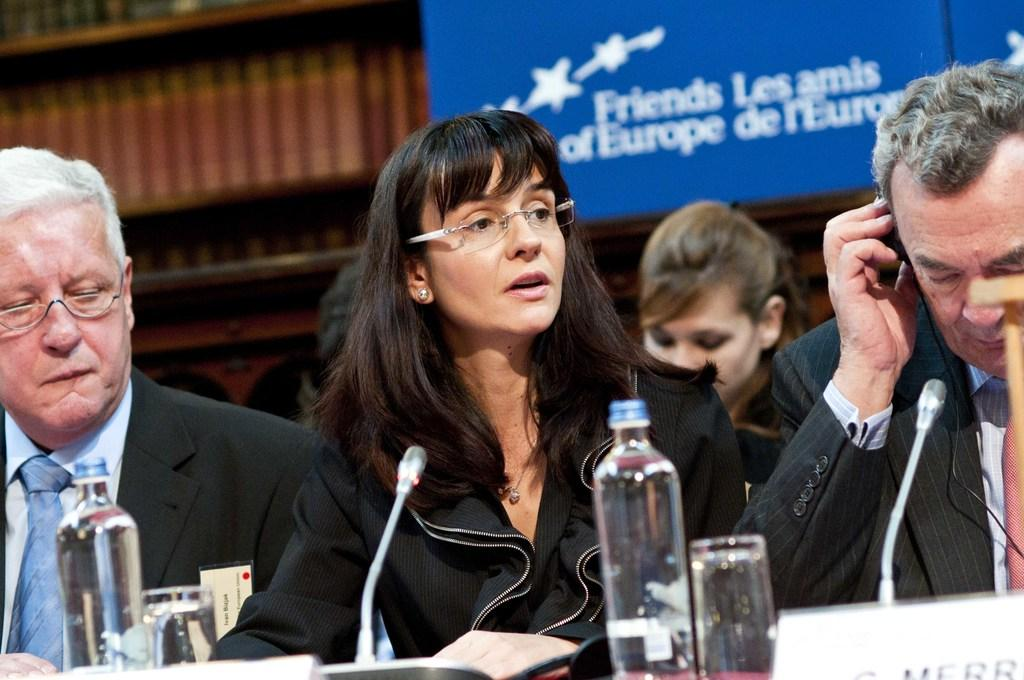What are the people in the image doing? There are persons sitting in the image. What object is present that is typically used for amplifying sound? There is a microphone in the image. What type of containers can be seen in the image? There are bottles and a glass in the image. What items are used for identification purposes in the image? There are name boards in the image. What can be seen in the background of the image? There is a banner in the background of the image. How many people are crying in the image? There is no indication in the image that anyone is crying; the people are sitting. What type of action is the person performing with the banner in the image? There is no person interacting with the banner in the image; it is simply present in the background. 